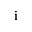Convert formula to latex. <formula><loc_0><loc_0><loc_500><loc_500>i</formula> 